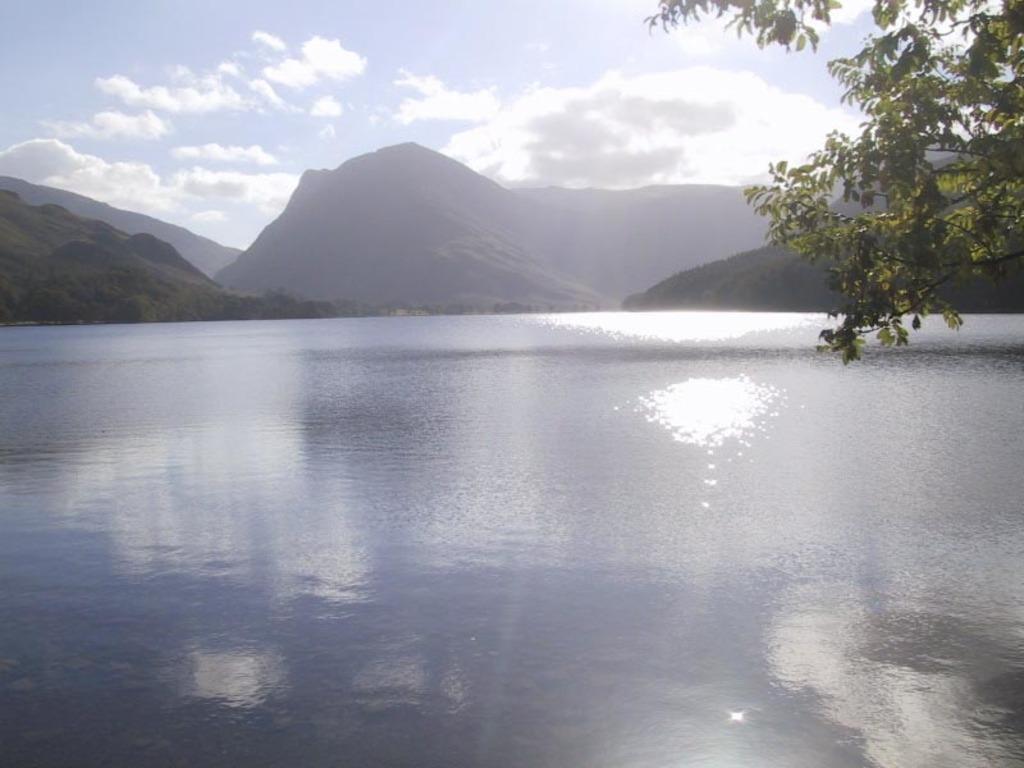Can you describe this image briefly? In this image it seems like a scenery in which there is water at the bottom. In the background there are hills. On the right side top there is a tree. 